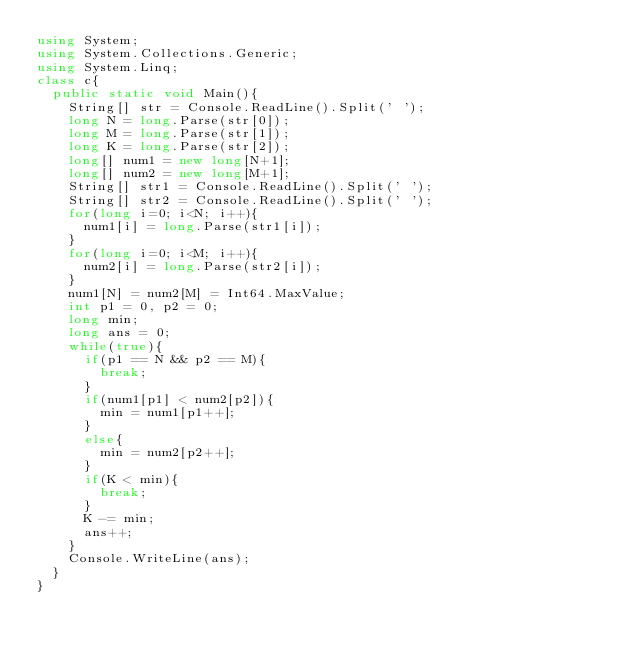<code> <loc_0><loc_0><loc_500><loc_500><_C#_>using System;
using System.Collections.Generic;
using System.Linq;
class c{
  public static void Main(){
    String[] str = Console.ReadLine().Split(' ');
    long N = long.Parse(str[0]);
    long M = long.Parse(str[1]);
    long K = long.Parse(str[2]);
    long[] num1 = new long[N+1];
    long[] num2 = new long[M+1];
    String[] str1 = Console.ReadLine().Split(' ');
    String[] str2 = Console.ReadLine().Split(' ');
    for(long i=0; i<N; i++){
      num1[i] = long.Parse(str1[i]);
    }
    for(long i=0; i<M; i++){
      num2[i] = long.Parse(str2[i]);
    }
    num1[N] = num2[M] = Int64.MaxValue;
    int p1 = 0, p2 = 0;
    long min;
    long ans = 0;
    while(true){
      if(p1 == N && p2 == M){
        break;
      }
      if(num1[p1] < num2[p2]){
        min = num1[p1++];
      }
      else{
        min = num2[p2++];
      }
      if(K < min){
        break;
      }
      K -= min;
      ans++;
    }
    Console.WriteLine(ans);
  }
}
</code> 